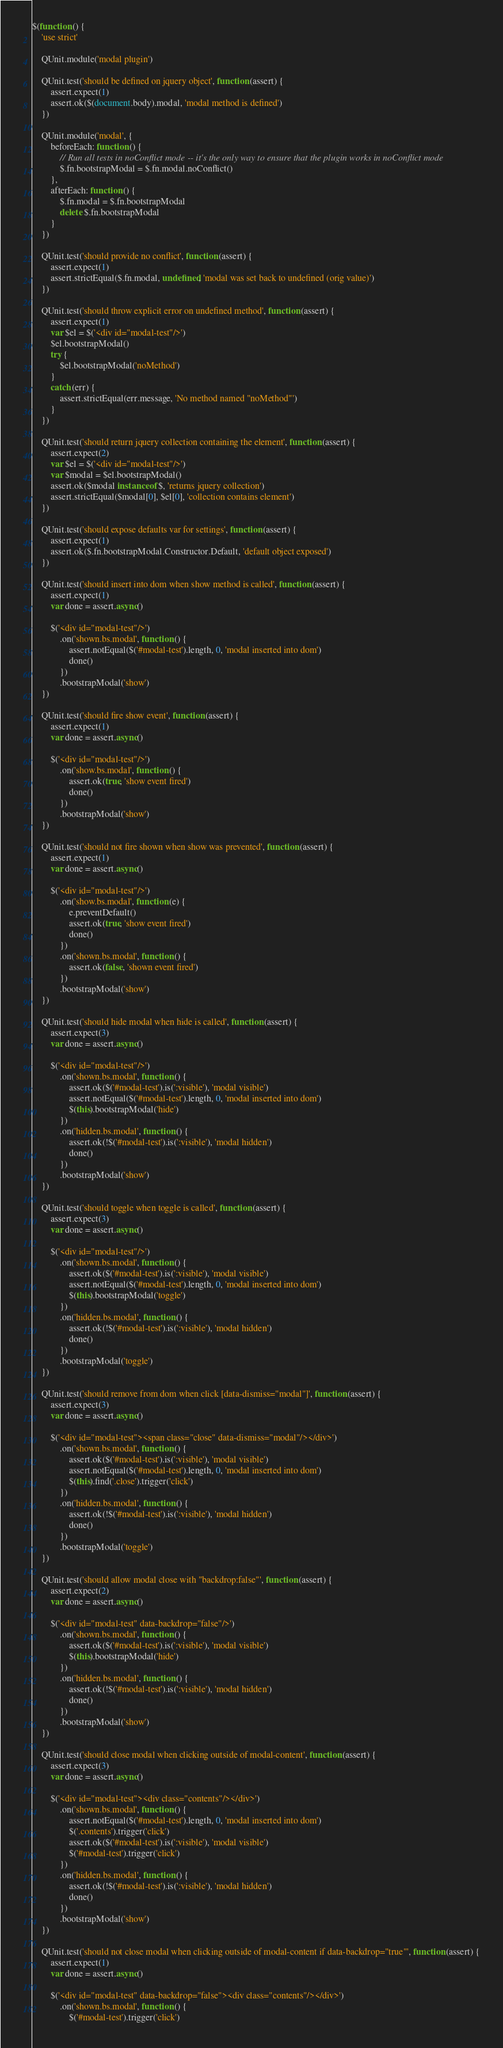Convert code to text. <code><loc_0><loc_0><loc_500><loc_500><_JavaScript_>$(function () {
    'use strict'

    QUnit.module('modal plugin')

    QUnit.test('should be defined on jquery object', function (assert) {
        assert.expect(1)
        assert.ok($(document.body).modal, 'modal method is defined')
    })

    QUnit.module('modal', {
        beforeEach: function () {
            // Run all tests in noConflict mode -- it's the only way to ensure that the plugin works in noConflict mode
            $.fn.bootstrapModal = $.fn.modal.noConflict()
        },
        afterEach: function () {
            $.fn.modal = $.fn.bootstrapModal
            delete $.fn.bootstrapModal
        }
    })

    QUnit.test('should provide no conflict', function (assert) {
        assert.expect(1)
        assert.strictEqual($.fn.modal, undefined, 'modal was set back to undefined (orig value)')
    })

    QUnit.test('should throw explicit error on undefined method', function (assert) {
        assert.expect(1)
        var $el = $('<div id="modal-test"/>')
        $el.bootstrapModal()
        try {
            $el.bootstrapModal('noMethod')
        }
        catch (err) {
            assert.strictEqual(err.message, 'No method named "noMethod"')
        }
    })

    QUnit.test('should return jquery collection containing the element', function (assert) {
        assert.expect(2)
        var $el = $('<div id="modal-test"/>')
        var $modal = $el.bootstrapModal()
        assert.ok($modal instanceof $, 'returns jquery collection')
        assert.strictEqual($modal[0], $el[0], 'collection contains element')
    })

    QUnit.test('should expose defaults var for settings', function (assert) {
        assert.expect(1)
        assert.ok($.fn.bootstrapModal.Constructor.Default, 'default object exposed')
    })

    QUnit.test('should insert into dom when show method is called', function (assert) {
        assert.expect(1)
        var done = assert.async()

        $('<div id="modal-test"/>')
            .on('shown.bs.modal', function () {
                assert.notEqual($('#modal-test').length, 0, 'modal inserted into dom')
                done()
            })
            .bootstrapModal('show')
    })

    QUnit.test('should fire show event', function (assert) {
        assert.expect(1)
        var done = assert.async()

        $('<div id="modal-test"/>')
            .on('show.bs.modal', function () {
                assert.ok(true, 'show event fired')
                done()
            })
            .bootstrapModal('show')
    })

    QUnit.test('should not fire shown when show was prevented', function (assert) {
        assert.expect(1)
        var done = assert.async()

        $('<div id="modal-test"/>')
            .on('show.bs.modal', function (e) {
                e.preventDefault()
                assert.ok(true, 'show event fired')
                done()
            })
            .on('shown.bs.modal', function () {
                assert.ok(false, 'shown event fired')
            })
            .bootstrapModal('show')
    })

    QUnit.test('should hide modal when hide is called', function (assert) {
        assert.expect(3)
        var done = assert.async()

        $('<div id="modal-test"/>')
            .on('shown.bs.modal', function () {
                assert.ok($('#modal-test').is(':visible'), 'modal visible')
                assert.notEqual($('#modal-test').length, 0, 'modal inserted into dom')
                $(this).bootstrapModal('hide')
            })
            .on('hidden.bs.modal', function () {
                assert.ok(!$('#modal-test').is(':visible'), 'modal hidden')
                done()
            })
            .bootstrapModal('show')
    })

    QUnit.test('should toggle when toggle is called', function (assert) {
        assert.expect(3)
        var done = assert.async()

        $('<div id="modal-test"/>')
            .on('shown.bs.modal', function () {
                assert.ok($('#modal-test').is(':visible'), 'modal visible')
                assert.notEqual($('#modal-test').length, 0, 'modal inserted into dom')
                $(this).bootstrapModal('toggle')
            })
            .on('hidden.bs.modal', function () {
                assert.ok(!$('#modal-test').is(':visible'), 'modal hidden')
                done()
            })
            .bootstrapModal('toggle')
    })

    QUnit.test('should remove from dom when click [data-dismiss="modal"]', function (assert) {
        assert.expect(3)
        var done = assert.async()

        $('<div id="modal-test"><span class="close" data-dismiss="modal"/></div>')
            .on('shown.bs.modal', function () {
                assert.ok($('#modal-test').is(':visible'), 'modal visible')
                assert.notEqual($('#modal-test').length, 0, 'modal inserted into dom')
                $(this).find('.close').trigger('click')
            })
            .on('hidden.bs.modal', function () {
                assert.ok(!$('#modal-test').is(':visible'), 'modal hidden')
                done()
            })
            .bootstrapModal('toggle')
    })

    QUnit.test('should allow modal close with "backdrop:false"', function (assert) {
        assert.expect(2)
        var done = assert.async()

        $('<div id="modal-test" data-backdrop="false"/>')
            .on('shown.bs.modal', function () {
                assert.ok($('#modal-test').is(':visible'), 'modal visible')
                $(this).bootstrapModal('hide')
            })
            .on('hidden.bs.modal', function () {
                assert.ok(!$('#modal-test').is(':visible'), 'modal hidden')
                done()
            })
            .bootstrapModal('show')
    })

    QUnit.test('should close modal when clicking outside of modal-content', function (assert) {
        assert.expect(3)
        var done = assert.async()

        $('<div id="modal-test"><div class="contents"/></div>')
            .on('shown.bs.modal', function () {
                assert.notEqual($('#modal-test').length, 0, 'modal inserted into dom')
                $('.contents').trigger('click')
                assert.ok($('#modal-test').is(':visible'), 'modal visible')
                $('#modal-test').trigger('click')
            })
            .on('hidden.bs.modal', function () {
                assert.ok(!$('#modal-test').is(':visible'), 'modal hidden')
                done()
            })
            .bootstrapModal('show')
    })

    QUnit.test('should not close modal when clicking outside of modal-content if data-backdrop="true"', function (assert) {
        assert.expect(1)
        var done = assert.async()

        $('<div id="modal-test" data-backdrop="false"><div class="contents"/></div>')
            .on('shown.bs.modal', function () {
                $('#modal-test').trigger('click')</code> 